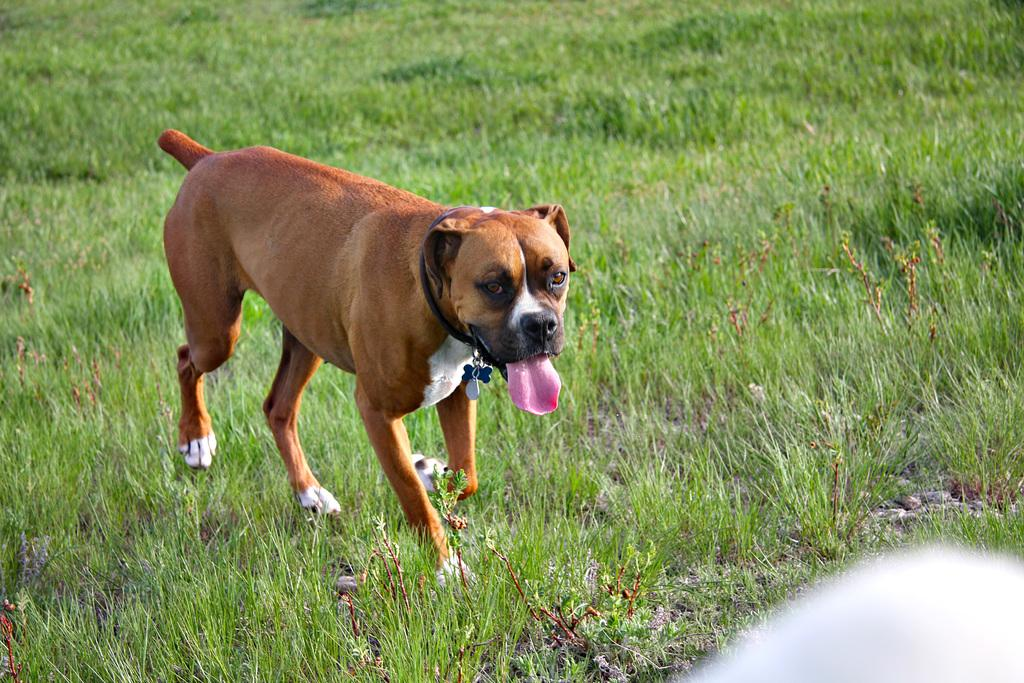What type of animal is present in the image? There is a dog in the image. What is the dog's location in the image? The dog is on the surface of the grass. What type of string is the dog playing with in the image? There is no string present in the image; the dog is simply on the grass. 